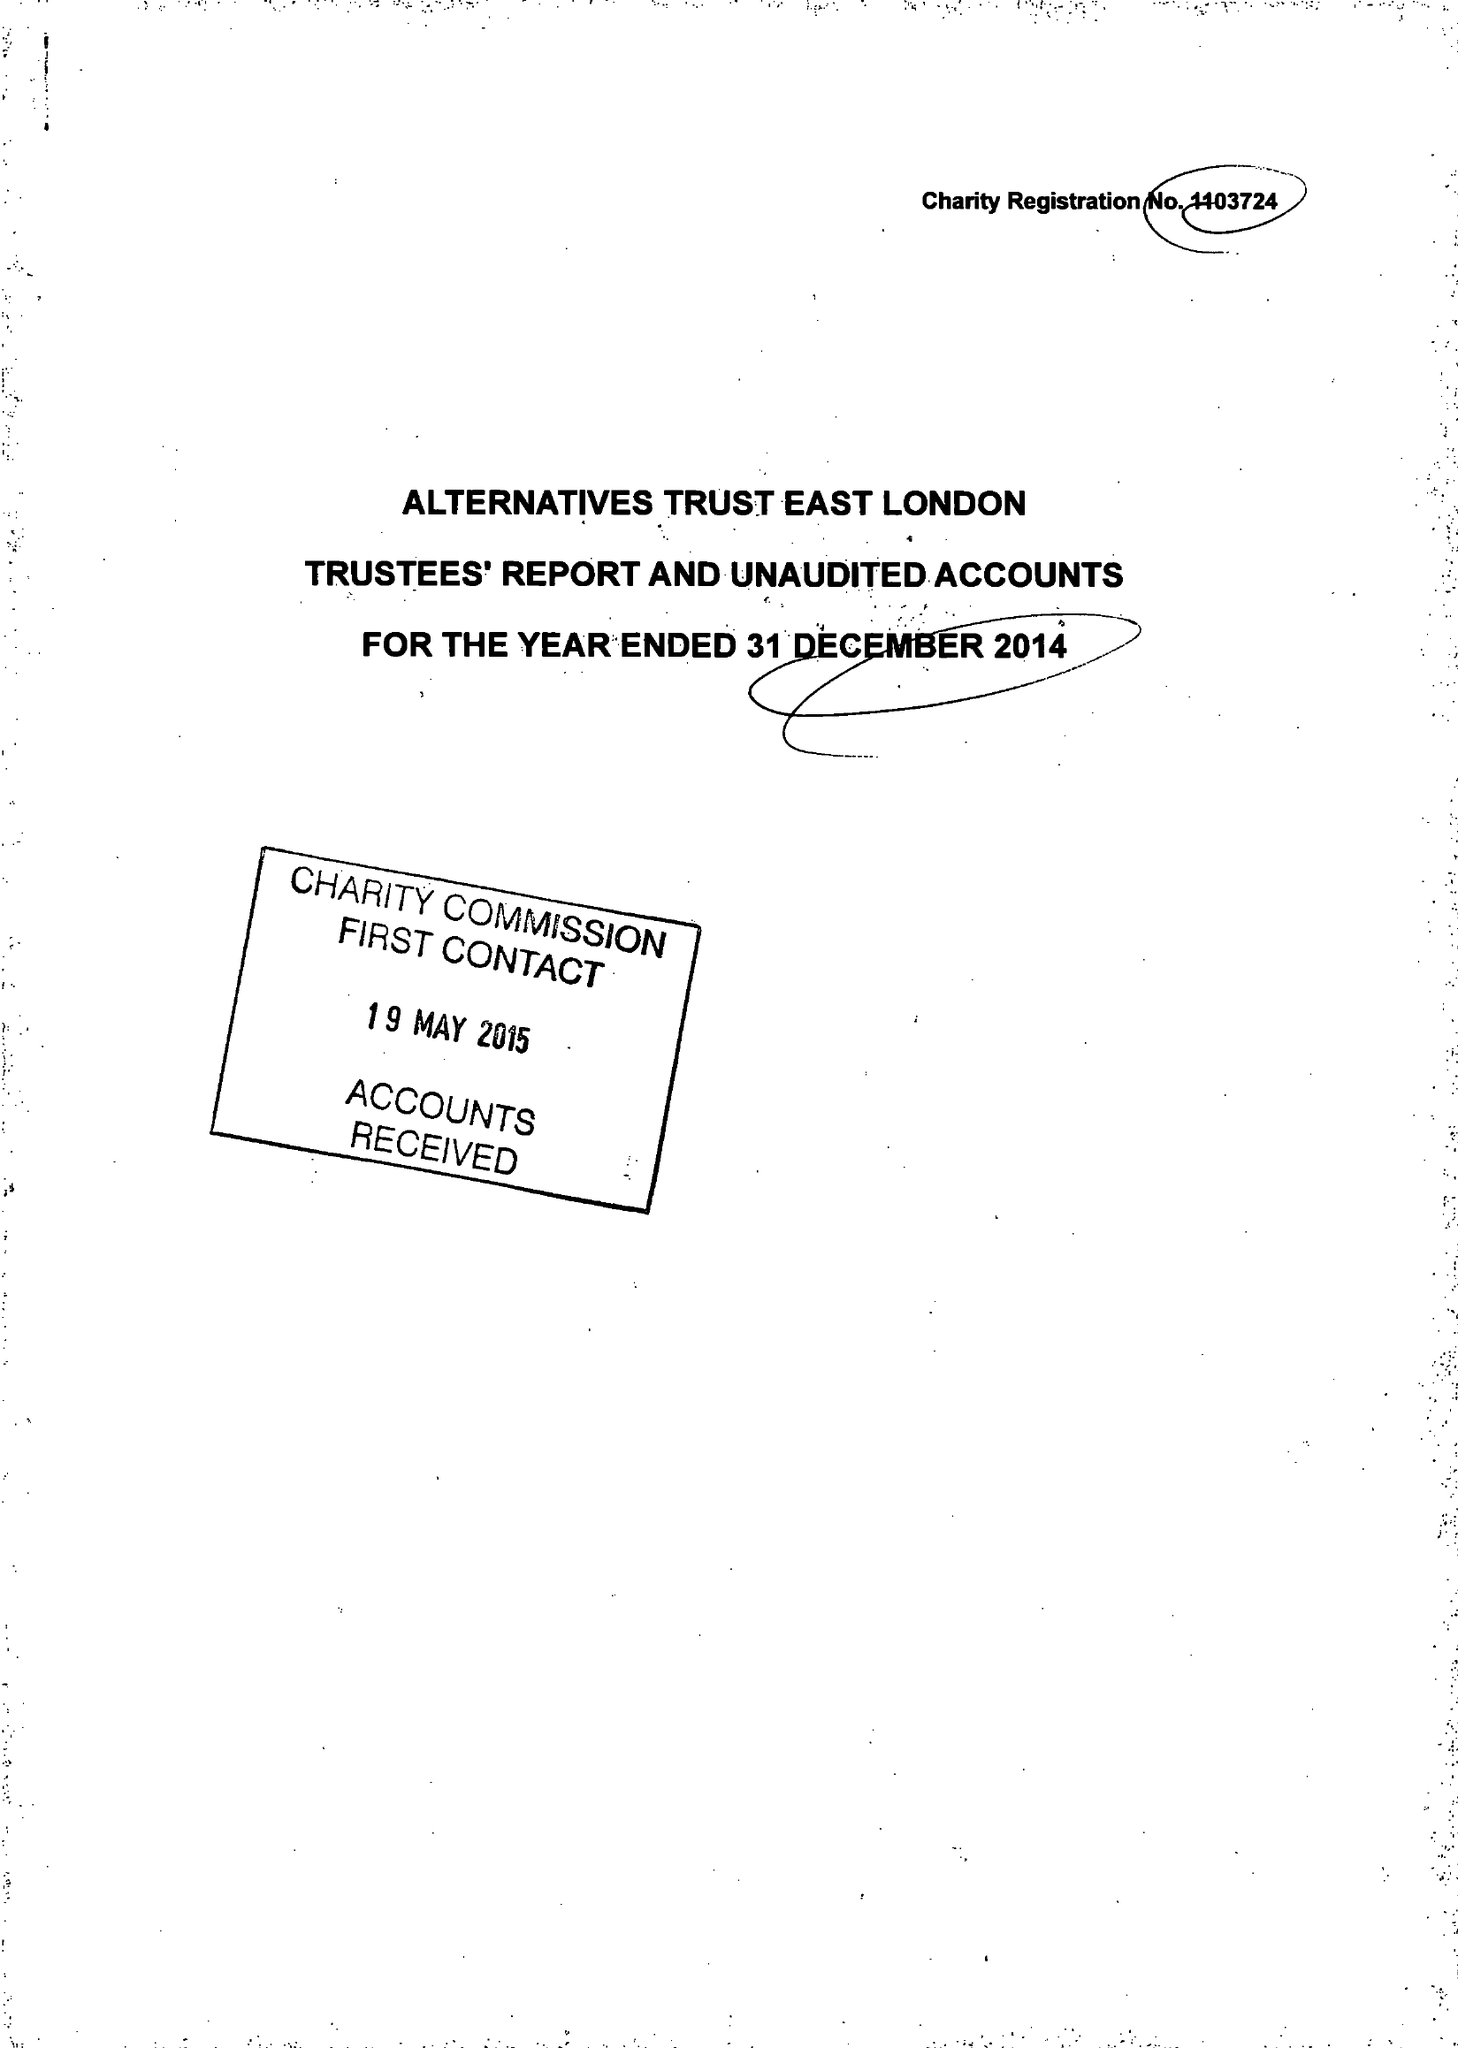What is the value for the report_date?
Answer the question using a single word or phrase. 2014-12-31 